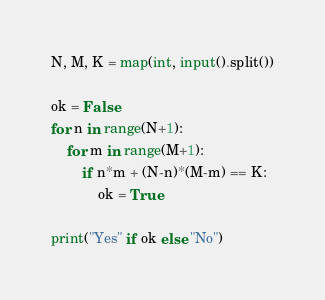<code> <loc_0><loc_0><loc_500><loc_500><_Python_>N, M, K = map(int, input().split())

ok = False
for n in range(N+1):
    for m in range(M+1):
        if n*m + (N-n)*(M-m) == K:
            ok = True

print("Yes" if ok else "No")</code> 